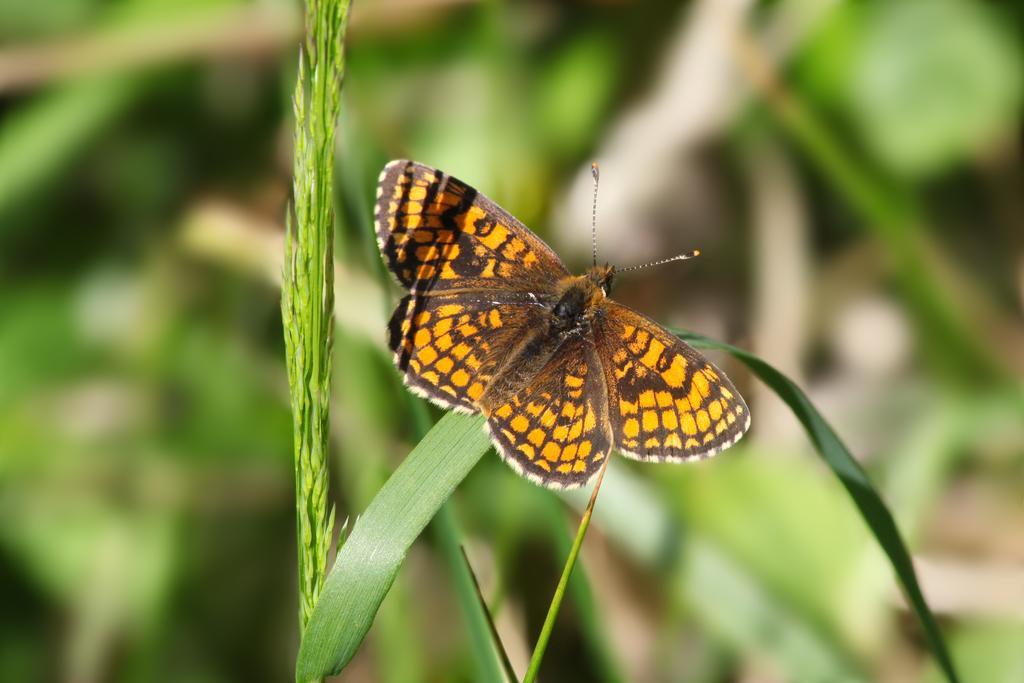Could you give a brief overview of what you see in this image? There is a butterfly in the center of the image on a leaf of a plant and the background is blurry. 